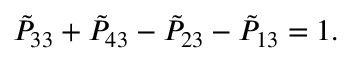Convert formula to latex. <formula><loc_0><loc_0><loc_500><loc_500>{ \tilde { P } } _ { 3 3 } + { \tilde { P } } _ { 4 3 } - { \tilde { P } } _ { 2 3 } - { \tilde { P } } _ { 1 3 } = 1 .</formula> 